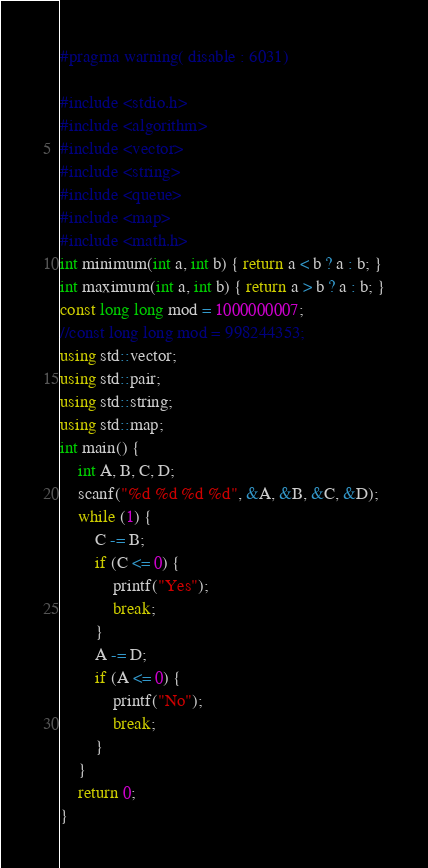Convert code to text. <code><loc_0><loc_0><loc_500><loc_500><_C++_>#pragma warning( disable : 6031)

#include <stdio.h>
#include <algorithm>
#include <vector>
#include <string>
#include <queue>
#include <map>
#include <math.h>
int minimum(int a, int b) { return a < b ? a : b; }
int maximum(int a, int b) { return a > b ? a : b; }
const long long mod = 1000000007;
//const long long mod = 998244353;
using std::vector;
using std::pair;
using std::string;
using std::map;
int main() {
	int A, B, C, D;
	scanf("%d %d %d %d", &A, &B, &C, &D);
	while (1) {
		C -= B;
		if (C <= 0) {
			printf("Yes");
			break;
		}
		A -= D;
		if (A <= 0) {
			printf("No");
			break;
		}
	}
	return 0;
}</code> 